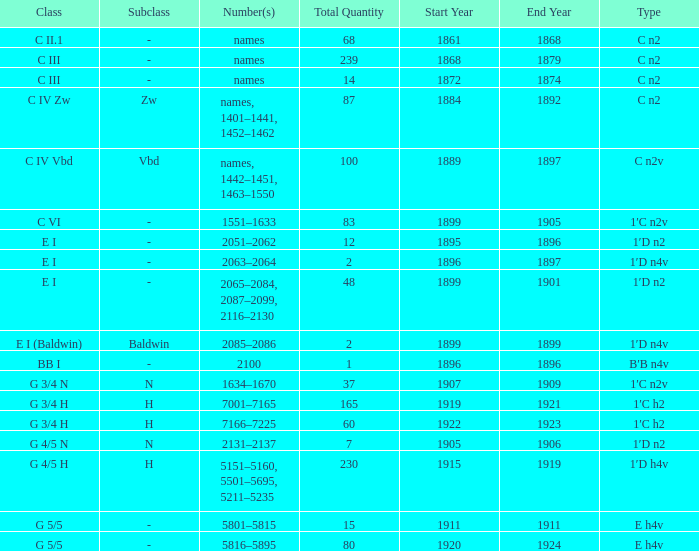Which Year(s) of Manufacture has a Quantity larger than 60, and a Number(s) of 7001–7165? 1919–1921. 